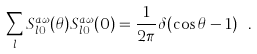Convert formula to latex. <formula><loc_0><loc_0><loc_500><loc_500>\sum _ { l } S _ { l 0 } ^ { a \omega } ( \theta ) S _ { l 0 } ^ { a \omega } ( 0 ) = \frac { 1 } { 2 \pi } \delta ( \cos \theta - 1 ) \ .</formula> 